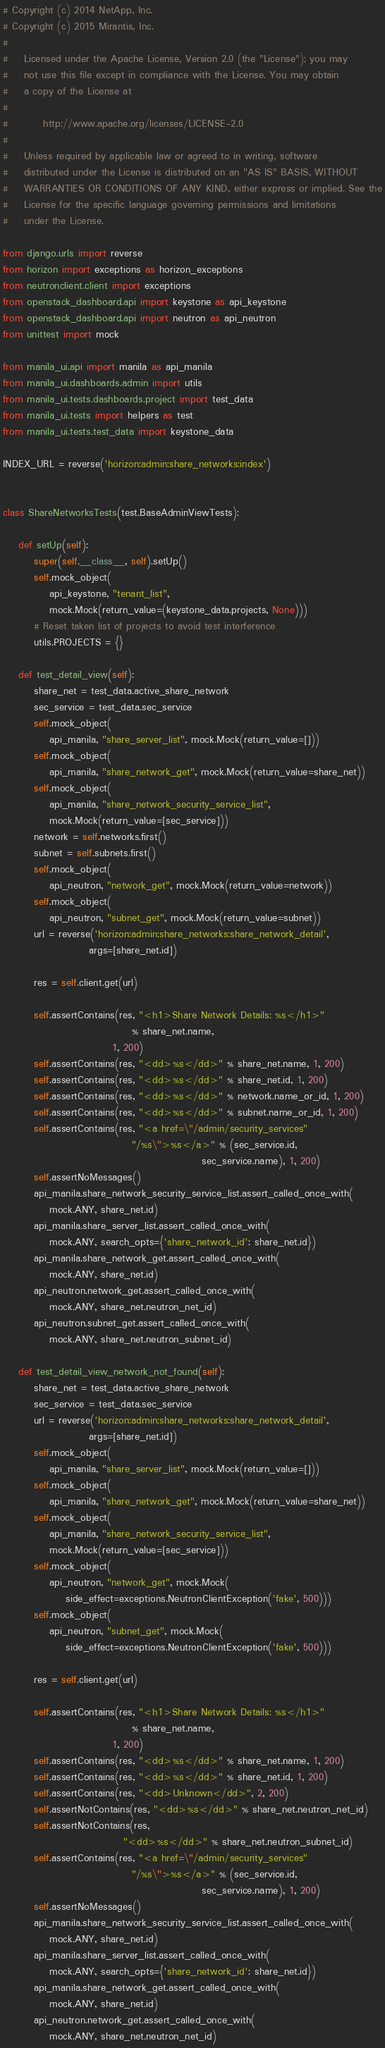<code> <loc_0><loc_0><loc_500><loc_500><_Python_># Copyright (c) 2014 NetApp, Inc.
# Copyright (c) 2015 Mirantis, Inc.
#
#    Licensed under the Apache License, Version 2.0 (the "License"); you may
#    not use this file except in compliance with the License. You may obtain
#    a copy of the License at
#
#         http://www.apache.org/licenses/LICENSE-2.0
#
#    Unless required by applicable law or agreed to in writing, software
#    distributed under the License is distributed on an "AS IS" BASIS, WITHOUT
#    WARRANTIES OR CONDITIONS OF ANY KIND, either express or implied. See the
#    License for the specific language governing permissions and limitations
#    under the License.

from django.urls import reverse
from horizon import exceptions as horizon_exceptions
from neutronclient.client import exceptions
from openstack_dashboard.api import keystone as api_keystone
from openstack_dashboard.api import neutron as api_neutron
from unittest import mock

from manila_ui.api import manila as api_manila
from manila_ui.dashboards.admin import utils
from manila_ui.tests.dashboards.project import test_data
from manila_ui.tests import helpers as test
from manila_ui.tests.test_data import keystone_data

INDEX_URL = reverse('horizon:admin:share_networks:index')


class ShareNetworksTests(test.BaseAdminViewTests):

    def setUp(self):
        super(self.__class__, self).setUp()
        self.mock_object(
            api_keystone, "tenant_list",
            mock.Mock(return_value=(keystone_data.projects, None)))
        # Reset taken list of projects to avoid test interference
        utils.PROJECTS = {}

    def test_detail_view(self):
        share_net = test_data.active_share_network
        sec_service = test_data.sec_service
        self.mock_object(
            api_manila, "share_server_list", mock.Mock(return_value=[]))
        self.mock_object(
            api_manila, "share_network_get", mock.Mock(return_value=share_net))
        self.mock_object(
            api_manila, "share_network_security_service_list",
            mock.Mock(return_value=[sec_service]))
        network = self.networks.first()
        subnet = self.subnets.first()
        self.mock_object(
            api_neutron, "network_get", mock.Mock(return_value=network))
        self.mock_object(
            api_neutron, "subnet_get", mock.Mock(return_value=subnet))
        url = reverse('horizon:admin:share_networks:share_network_detail',
                      args=[share_net.id])

        res = self.client.get(url)

        self.assertContains(res, "<h1>Share Network Details: %s</h1>"
                                 % share_net.name,
                            1, 200)
        self.assertContains(res, "<dd>%s</dd>" % share_net.name, 1, 200)
        self.assertContains(res, "<dd>%s</dd>" % share_net.id, 1, 200)
        self.assertContains(res, "<dd>%s</dd>" % network.name_or_id, 1, 200)
        self.assertContains(res, "<dd>%s</dd>" % subnet.name_or_id, 1, 200)
        self.assertContains(res, "<a href=\"/admin/security_services"
                                 "/%s\">%s</a>" % (sec_service.id,
                                                   sec_service.name), 1, 200)
        self.assertNoMessages()
        api_manila.share_network_security_service_list.assert_called_once_with(
            mock.ANY, share_net.id)
        api_manila.share_server_list.assert_called_once_with(
            mock.ANY, search_opts={'share_network_id': share_net.id})
        api_manila.share_network_get.assert_called_once_with(
            mock.ANY, share_net.id)
        api_neutron.network_get.assert_called_once_with(
            mock.ANY, share_net.neutron_net_id)
        api_neutron.subnet_get.assert_called_once_with(
            mock.ANY, share_net.neutron_subnet_id)

    def test_detail_view_network_not_found(self):
        share_net = test_data.active_share_network
        sec_service = test_data.sec_service
        url = reverse('horizon:admin:share_networks:share_network_detail',
                      args=[share_net.id])
        self.mock_object(
            api_manila, "share_server_list", mock.Mock(return_value=[]))
        self.mock_object(
            api_manila, "share_network_get", mock.Mock(return_value=share_net))
        self.mock_object(
            api_manila, "share_network_security_service_list",
            mock.Mock(return_value=[sec_service]))
        self.mock_object(
            api_neutron, "network_get", mock.Mock(
                side_effect=exceptions.NeutronClientException('fake', 500)))
        self.mock_object(
            api_neutron, "subnet_get", mock.Mock(
                side_effect=exceptions.NeutronClientException('fake', 500)))

        res = self.client.get(url)

        self.assertContains(res, "<h1>Share Network Details: %s</h1>"
                                 % share_net.name,
                            1, 200)
        self.assertContains(res, "<dd>%s</dd>" % share_net.name, 1, 200)
        self.assertContains(res, "<dd>%s</dd>" % share_net.id, 1, 200)
        self.assertContains(res, "<dd>Unknown</dd>", 2, 200)
        self.assertNotContains(res, "<dd>%s</dd>" % share_net.neutron_net_id)
        self.assertNotContains(res,
                               "<dd>%s</dd>" % share_net.neutron_subnet_id)
        self.assertContains(res, "<a href=\"/admin/security_services"
                                 "/%s\">%s</a>" % (sec_service.id,
                                                   sec_service.name), 1, 200)
        self.assertNoMessages()
        api_manila.share_network_security_service_list.assert_called_once_with(
            mock.ANY, share_net.id)
        api_manila.share_server_list.assert_called_once_with(
            mock.ANY, search_opts={'share_network_id': share_net.id})
        api_manila.share_network_get.assert_called_once_with(
            mock.ANY, share_net.id)
        api_neutron.network_get.assert_called_once_with(
            mock.ANY, share_net.neutron_net_id)</code> 